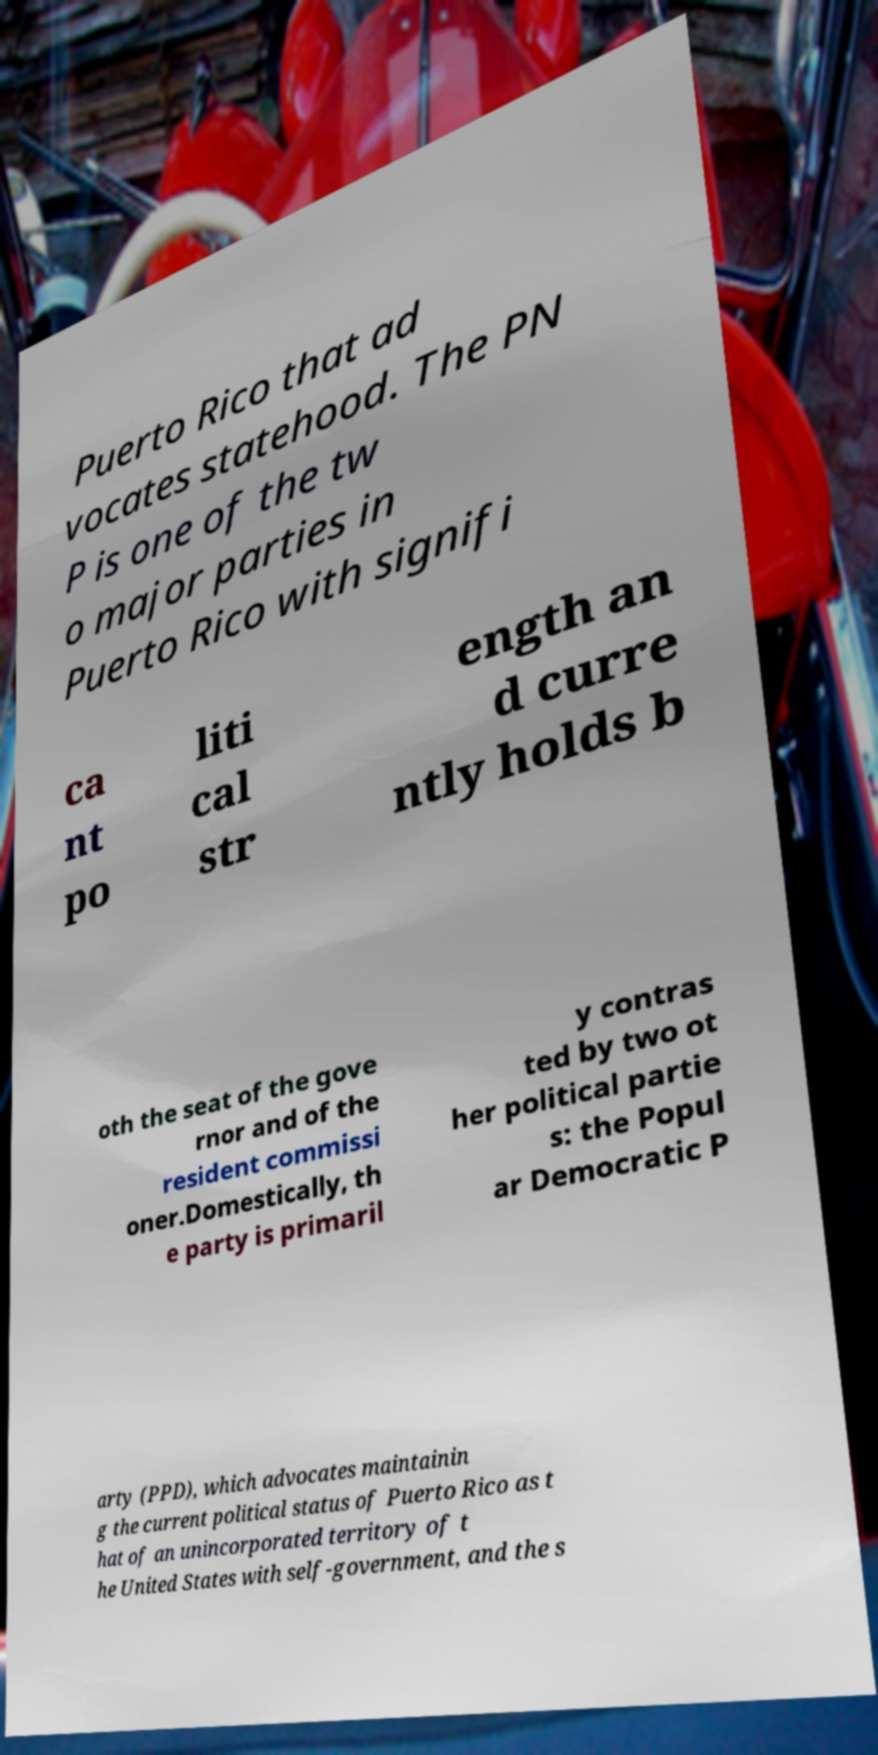What messages or text are displayed in this image? I need them in a readable, typed format. Puerto Rico that ad vocates statehood. The PN P is one of the tw o major parties in Puerto Rico with signifi ca nt po liti cal str ength an d curre ntly holds b oth the seat of the gove rnor and of the resident commissi oner.Domestically, th e party is primaril y contras ted by two ot her political partie s: the Popul ar Democratic P arty (PPD), which advocates maintainin g the current political status of Puerto Rico as t hat of an unincorporated territory of t he United States with self-government, and the s 